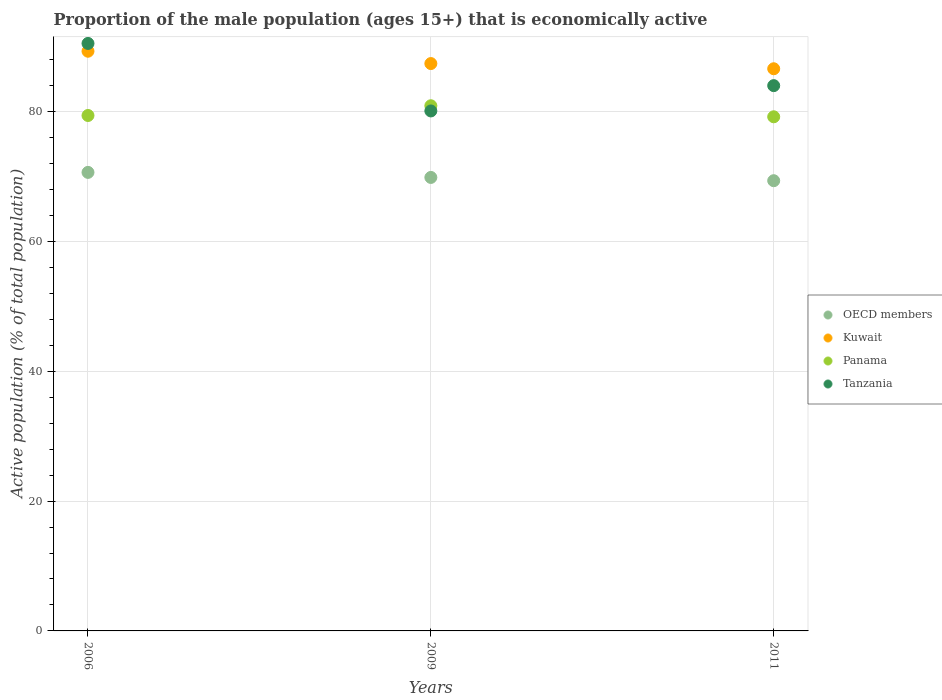Is the number of dotlines equal to the number of legend labels?
Your answer should be very brief. Yes. What is the proportion of the male population that is economically active in OECD members in 2009?
Your answer should be very brief. 69.86. Across all years, what is the maximum proportion of the male population that is economically active in Tanzania?
Your answer should be very brief. 90.5. Across all years, what is the minimum proportion of the male population that is economically active in Tanzania?
Keep it short and to the point. 80.1. In which year was the proportion of the male population that is economically active in Tanzania maximum?
Offer a very short reply. 2006. What is the total proportion of the male population that is economically active in Tanzania in the graph?
Ensure brevity in your answer.  254.6. What is the difference between the proportion of the male population that is economically active in OECD members in 2006 and that in 2009?
Give a very brief answer. 0.78. What is the difference between the proportion of the male population that is economically active in Kuwait in 2006 and the proportion of the male population that is economically active in Tanzania in 2011?
Make the answer very short. 5.3. What is the average proportion of the male population that is economically active in Kuwait per year?
Your answer should be compact. 87.77. In the year 2011, what is the difference between the proportion of the male population that is economically active in Tanzania and proportion of the male population that is economically active in OECD members?
Your answer should be very brief. 14.65. What is the ratio of the proportion of the male population that is economically active in Tanzania in 2009 to that in 2011?
Give a very brief answer. 0.95. Is the proportion of the male population that is economically active in Panama in 2006 less than that in 2011?
Your answer should be compact. No. What is the difference between the highest and the second highest proportion of the male population that is economically active in Kuwait?
Provide a short and direct response. 1.9. What is the difference between the highest and the lowest proportion of the male population that is economically active in OECD members?
Provide a succinct answer. 1.28. In how many years, is the proportion of the male population that is economically active in OECD members greater than the average proportion of the male population that is economically active in OECD members taken over all years?
Your answer should be compact. 1. Is it the case that in every year, the sum of the proportion of the male population that is economically active in Kuwait and proportion of the male population that is economically active in OECD members  is greater than the sum of proportion of the male population that is economically active in Tanzania and proportion of the male population that is economically active in Panama?
Provide a short and direct response. Yes. Is it the case that in every year, the sum of the proportion of the male population that is economically active in Tanzania and proportion of the male population that is economically active in Panama  is greater than the proportion of the male population that is economically active in Kuwait?
Your answer should be very brief. Yes. Is the proportion of the male population that is economically active in Tanzania strictly greater than the proportion of the male population that is economically active in Kuwait over the years?
Your response must be concise. No. Is the proportion of the male population that is economically active in Panama strictly less than the proportion of the male population that is economically active in Kuwait over the years?
Ensure brevity in your answer.  Yes. How many dotlines are there?
Your answer should be very brief. 4. Are the values on the major ticks of Y-axis written in scientific E-notation?
Give a very brief answer. No. Does the graph contain any zero values?
Give a very brief answer. No. Does the graph contain grids?
Provide a succinct answer. Yes. How are the legend labels stacked?
Ensure brevity in your answer.  Vertical. What is the title of the graph?
Make the answer very short. Proportion of the male population (ages 15+) that is economically active. What is the label or title of the X-axis?
Make the answer very short. Years. What is the label or title of the Y-axis?
Give a very brief answer. Active population (% of total population). What is the Active population (% of total population) of OECD members in 2006?
Provide a succinct answer. 70.64. What is the Active population (% of total population) of Kuwait in 2006?
Ensure brevity in your answer.  89.3. What is the Active population (% of total population) in Panama in 2006?
Offer a terse response. 79.4. What is the Active population (% of total population) in Tanzania in 2006?
Give a very brief answer. 90.5. What is the Active population (% of total population) in OECD members in 2009?
Keep it short and to the point. 69.86. What is the Active population (% of total population) in Kuwait in 2009?
Give a very brief answer. 87.4. What is the Active population (% of total population) of Panama in 2009?
Provide a short and direct response. 80.9. What is the Active population (% of total population) of Tanzania in 2009?
Your answer should be very brief. 80.1. What is the Active population (% of total population) of OECD members in 2011?
Provide a succinct answer. 69.35. What is the Active population (% of total population) of Kuwait in 2011?
Make the answer very short. 86.6. What is the Active population (% of total population) in Panama in 2011?
Provide a short and direct response. 79.2. What is the Active population (% of total population) of Tanzania in 2011?
Give a very brief answer. 84. Across all years, what is the maximum Active population (% of total population) of OECD members?
Give a very brief answer. 70.64. Across all years, what is the maximum Active population (% of total population) of Kuwait?
Your answer should be very brief. 89.3. Across all years, what is the maximum Active population (% of total population) in Panama?
Your answer should be compact. 80.9. Across all years, what is the maximum Active population (% of total population) in Tanzania?
Provide a short and direct response. 90.5. Across all years, what is the minimum Active population (% of total population) of OECD members?
Provide a succinct answer. 69.35. Across all years, what is the minimum Active population (% of total population) in Kuwait?
Ensure brevity in your answer.  86.6. Across all years, what is the minimum Active population (% of total population) in Panama?
Provide a short and direct response. 79.2. Across all years, what is the minimum Active population (% of total population) in Tanzania?
Make the answer very short. 80.1. What is the total Active population (% of total population) in OECD members in the graph?
Provide a short and direct response. 209.85. What is the total Active population (% of total population) in Kuwait in the graph?
Your answer should be very brief. 263.3. What is the total Active population (% of total population) in Panama in the graph?
Your answer should be compact. 239.5. What is the total Active population (% of total population) in Tanzania in the graph?
Provide a succinct answer. 254.6. What is the difference between the Active population (% of total population) in OECD members in 2006 and that in 2009?
Your answer should be very brief. 0.78. What is the difference between the Active population (% of total population) of Kuwait in 2006 and that in 2009?
Provide a short and direct response. 1.9. What is the difference between the Active population (% of total population) in Tanzania in 2006 and that in 2009?
Make the answer very short. 10.4. What is the difference between the Active population (% of total population) of OECD members in 2006 and that in 2011?
Give a very brief answer. 1.28. What is the difference between the Active population (% of total population) of Panama in 2006 and that in 2011?
Ensure brevity in your answer.  0.2. What is the difference between the Active population (% of total population) in Tanzania in 2006 and that in 2011?
Provide a succinct answer. 6.5. What is the difference between the Active population (% of total population) of OECD members in 2009 and that in 2011?
Ensure brevity in your answer.  0.5. What is the difference between the Active population (% of total population) in Kuwait in 2009 and that in 2011?
Make the answer very short. 0.8. What is the difference between the Active population (% of total population) in OECD members in 2006 and the Active population (% of total population) in Kuwait in 2009?
Offer a terse response. -16.76. What is the difference between the Active population (% of total population) in OECD members in 2006 and the Active population (% of total population) in Panama in 2009?
Provide a short and direct response. -10.26. What is the difference between the Active population (% of total population) in OECD members in 2006 and the Active population (% of total population) in Tanzania in 2009?
Keep it short and to the point. -9.46. What is the difference between the Active population (% of total population) of Kuwait in 2006 and the Active population (% of total population) of Panama in 2009?
Offer a very short reply. 8.4. What is the difference between the Active population (% of total population) in Kuwait in 2006 and the Active population (% of total population) in Tanzania in 2009?
Your response must be concise. 9.2. What is the difference between the Active population (% of total population) of Panama in 2006 and the Active population (% of total population) of Tanzania in 2009?
Your answer should be very brief. -0.7. What is the difference between the Active population (% of total population) of OECD members in 2006 and the Active population (% of total population) of Kuwait in 2011?
Keep it short and to the point. -15.96. What is the difference between the Active population (% of total population) of OECD members in 2006 and the Active population (% of total population) of Panama in 2011?
Offer a terse response. -8.56. What is the difference between the Active population (% of total population) in OECD members in 2006 and the Active population (% of total population) in Tanzania in 2011?
Provide a succinct answer. -13.36. What is the difference between the Active population (% of total population) of Kuwait in 2006 and the Active population (% of total population) of Tanzania in 2011?
Your answer should be very brief. 5.3. What is the difference between the Active population (% of total population) of OECD members in 2009 and the Active population (% of total population) of Kuwait in 2011?
Your answer should be very brief. -16.74. What is the difference between the Active population (% of total population) of OECD members in 2009 and the Active population (% of total population) of Panama in 2011?
Your response must be concise. -9.34. What is the difference between the Active population (% of total population) in OECD members in 2009 and the Active population (% of total population) in Tanzania in 2011?
Offer a very short reply. -14.14. What is the difference between the Active population (% of total population) in Kuwait in 2009 and the Active population (% of total population) in Tanzania in 2011?
Your answer should be very brief. 3.4. What is the average Active population (% of total population) of OECD members per year?
Ensure brevity in your answer.  69.95. What is the average Active population (% of total population) of Kuwait per year?
Provide a short and direct response. 87.77. What is the average Active population (% of total population) in Panama per year?
Your response must be concise. 79.83. What is the average Active population (% of total population) in Tanzania per year?
Your response must be concise. 84.87. In the year 2006, what is the difference between the Active population (% of total population) of OECD members and Active population (% of total population) of Kuwait?
Keep it short and to the point. -18.66. In the year 2006, what is the difference between the Active population (% of total population) in OECD members and Active population (% of total population) in Panama?
Make the answer very short. -8.76. In the year 2006, what is the difference between the Active population (% of total population) in OECD members and Active population (% of total population) in Tanzania?
Keep it short and to the point. -19.86. In the year 2006, what is the difference between the Active population (% of total population) of Panama and Active population (% of total population) of Tanzania?
Make the answer very short. -11.1. In the year 2009, what is the difference between the Active population (% of total population) of OECD members and Active population (% of total population) of Kuwait?
Offer a terse response. -17.54. In the year 2009, what is the difference between the Active population (% of total population) in OECD members and Active population (% of total population) in Panama?
Keep it short and to the point. -11.04. In the year 2009, what is the difference between the Active population (% of total population) in OECD members and Active population (% of total population) in Tanzania?
Give a very brief answer. -10.24. In the year 2009, what is the difference between the Active population (% of total population) in Kuwait and Active population (% of total population) in Tanzania?
Ensure brevity in your answer.  7.3. In the year 2011, what is the difference between the Active population (% of total population) in OECD members and Active population (% of total population) in Kuwait?
Give a very brief answer. -17.25. In the year 2011, what is the difference between the Active population (% of total population) of OECD members and Active population (% of total population) of Panama?
Offer a very short reply. -9.85. In the year 2011, what is the difference between the Active population (% of total population) in OECD members and Active population (% of total population) in Tanzania?
Your response must be concise. -14.65. What is the ratio of the Active population (% of total population) of OECD members in 2006 to that in 2009?
Give a very brief answer. 1.01. What is the ratio of the Active population (% of total population) of Kuwait in 2006 to that in 2009?
Provide a short and direct response. 1.02. What is the ratio of the Active population (% of total population) of Panama in 2006 to that in 2009?
Provide a succinct answer. 0.98. What is the ratio of the Active population (% of total population) of Tanzania in 2006 to that in 2009?
Ensure brevity in your answer.  1.13. What is the ratio of the Active population (% of total population) in OECD members in 2006 to that in 2011?
Your response must be concise. 1.02. What is the ratio of the Active population (% of total population) in Kuwait in 2006 to that in 2011?
Your response must be concise. 1.03. What is the ratio of the Active population (% of total population) of Panama in 2006 to that in 2011?
Make the answer very short. 1. What is the ratio of the Active population (% of total population) in Tanzania in 2006 to that in 2011?
Your answer should be very brief. 1.08. What is the ratio of the Active population (% of total population) in OECD members in 2009 to that in 2011?
Your response must be concise. 1.01. What is the ratio of the Active population (% of total population) of Kuwait in 2009 to that in 2011?
Your response must be concise. 1.01. What is the ratio of the Active population (% of total population) in Panama in 2009 to that in 2011?
Offer a very short reply. 1.02. What is the ratio of the Active population (% of total population) of Tanzania in 2009 to that in 2011?
Provide a succinct answer. 0.95. What is the difference between the highest and the second highest Active population (% of total population) of OECD members?
Make the answer very short. 0.78. What is the difference between the highest and the second highest Active population (% of total population) of Kuwait?
Give a very brief answer. 1.9. What is the difference between the highest and the lowest Active population (% of total population) in OECD members?
Offer a very short reply. 1.28. What is the difference between the highest and the lowest Active population (% of total population) of Kuwait?
Offer a terse response. 2.7. What is the difference between the highest and the lowest Active population (% of total population) in Tanzania?
Offer a very short reply. 10.4. 